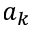<formula> <loc_0><loc_0><loc_500><loc_500>a _ { k }</formula> 